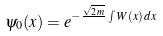<formula> <loc_0><loc_0><loc_500><loc_500>\psi _ { 0 } ( x ) = e ^ { - \frac { \sqrt { 2 \, m } } { } \int { W ( x ) \, d x } }</formula> 